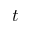<formula> <loc_0><loc_0><loc_500><loc_500>t</formula> 